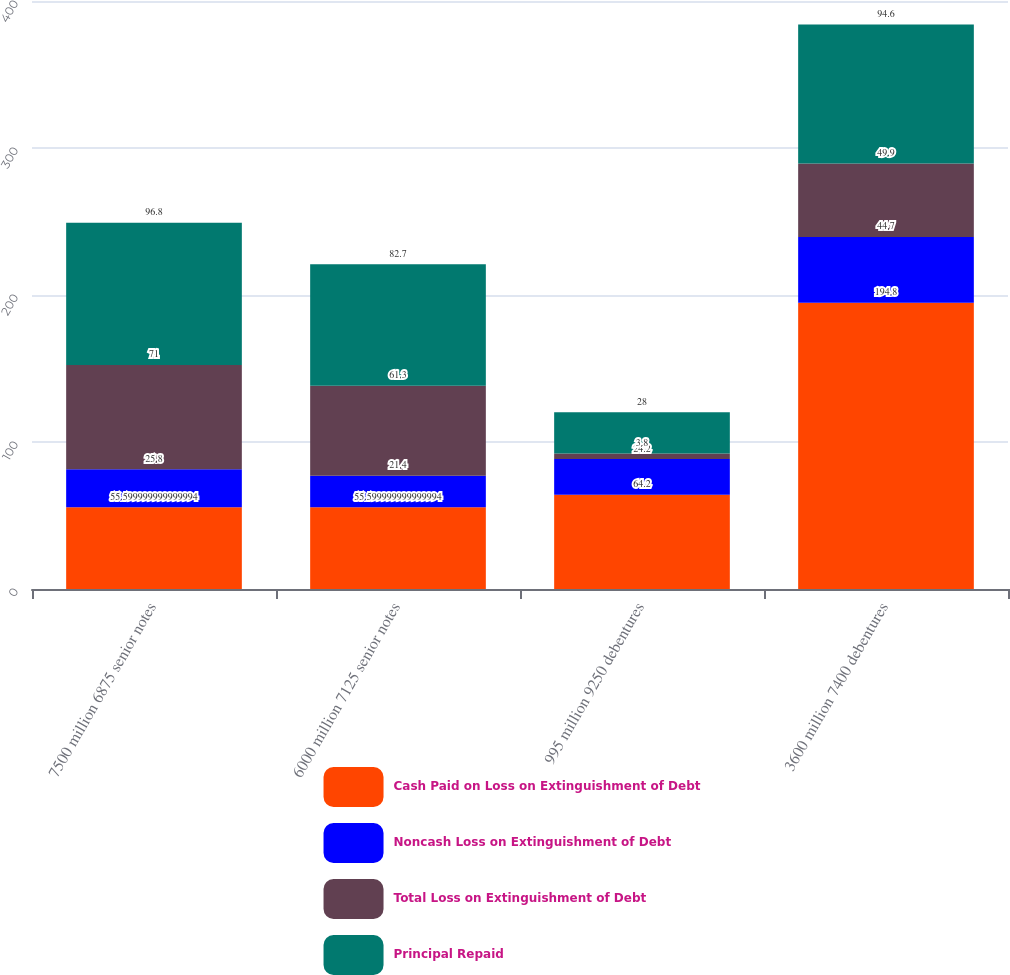Convert chart to OTSL. <chart><loc_0><loc_0><loc_500><loc_500><stacked_bar_chart><ecel><fcel>7500 million 6875 senior notes<fcel>6000 million 7125 senior notes<fcel>995 million 9250 debentures<fcel>3600 million 7400 debentures<nl><fcel>Cash Paid on Loss on Extinguishment of Debt<fcel>55.6<fcel>55.6<fcel>64.2<fcel>194.8<nl><fcel>Noncash Loss on Extinguishment of Debt<fcel>25.8<fcel>21.4<fcel>24.2<fcel>44.7<nl><fcel>Total Loss on Extinguishment of Debt<fcel>71<fcel>61.3<fcel>3.8<fcel>49.9<nl><fcel>Principal Repaid<fcel>96.8<fcel>82.7<fcel>28<fcel>94.6<nl></chart> 